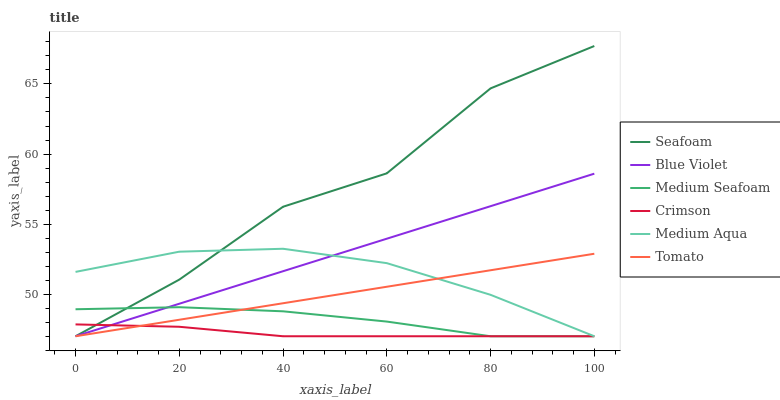Does Medium Aqua have the minimum area under the curve?
Answer yes or no. No. Does Medium Aqua have the maximum area under the curve?
Answer yes or no. No. Is Medium Aqua the smoothest?
Answer yes or no. No. Is Medium Aqua the roughest?
Answer yes or no. No. Does Medium Aqua have the highest value?
Answer yes or no. No. 